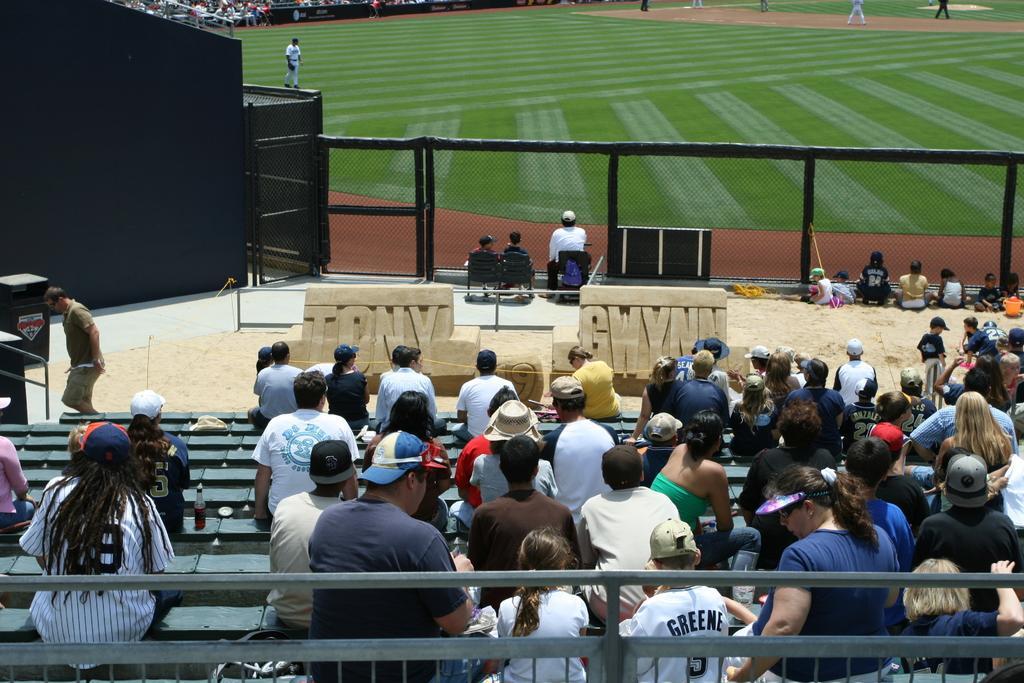Please provide a concise description of this image. At the bottom of the picture, we see people sitting on the benches. In the middle of the picture, we see children sitting on the chairs and on the sand. In front of them, we see a fence. We see people playing in the ground. In the background, we see people sitting on the chairs. On the left side, we see a wall in black color. This picture is clicked in the cricket field. 